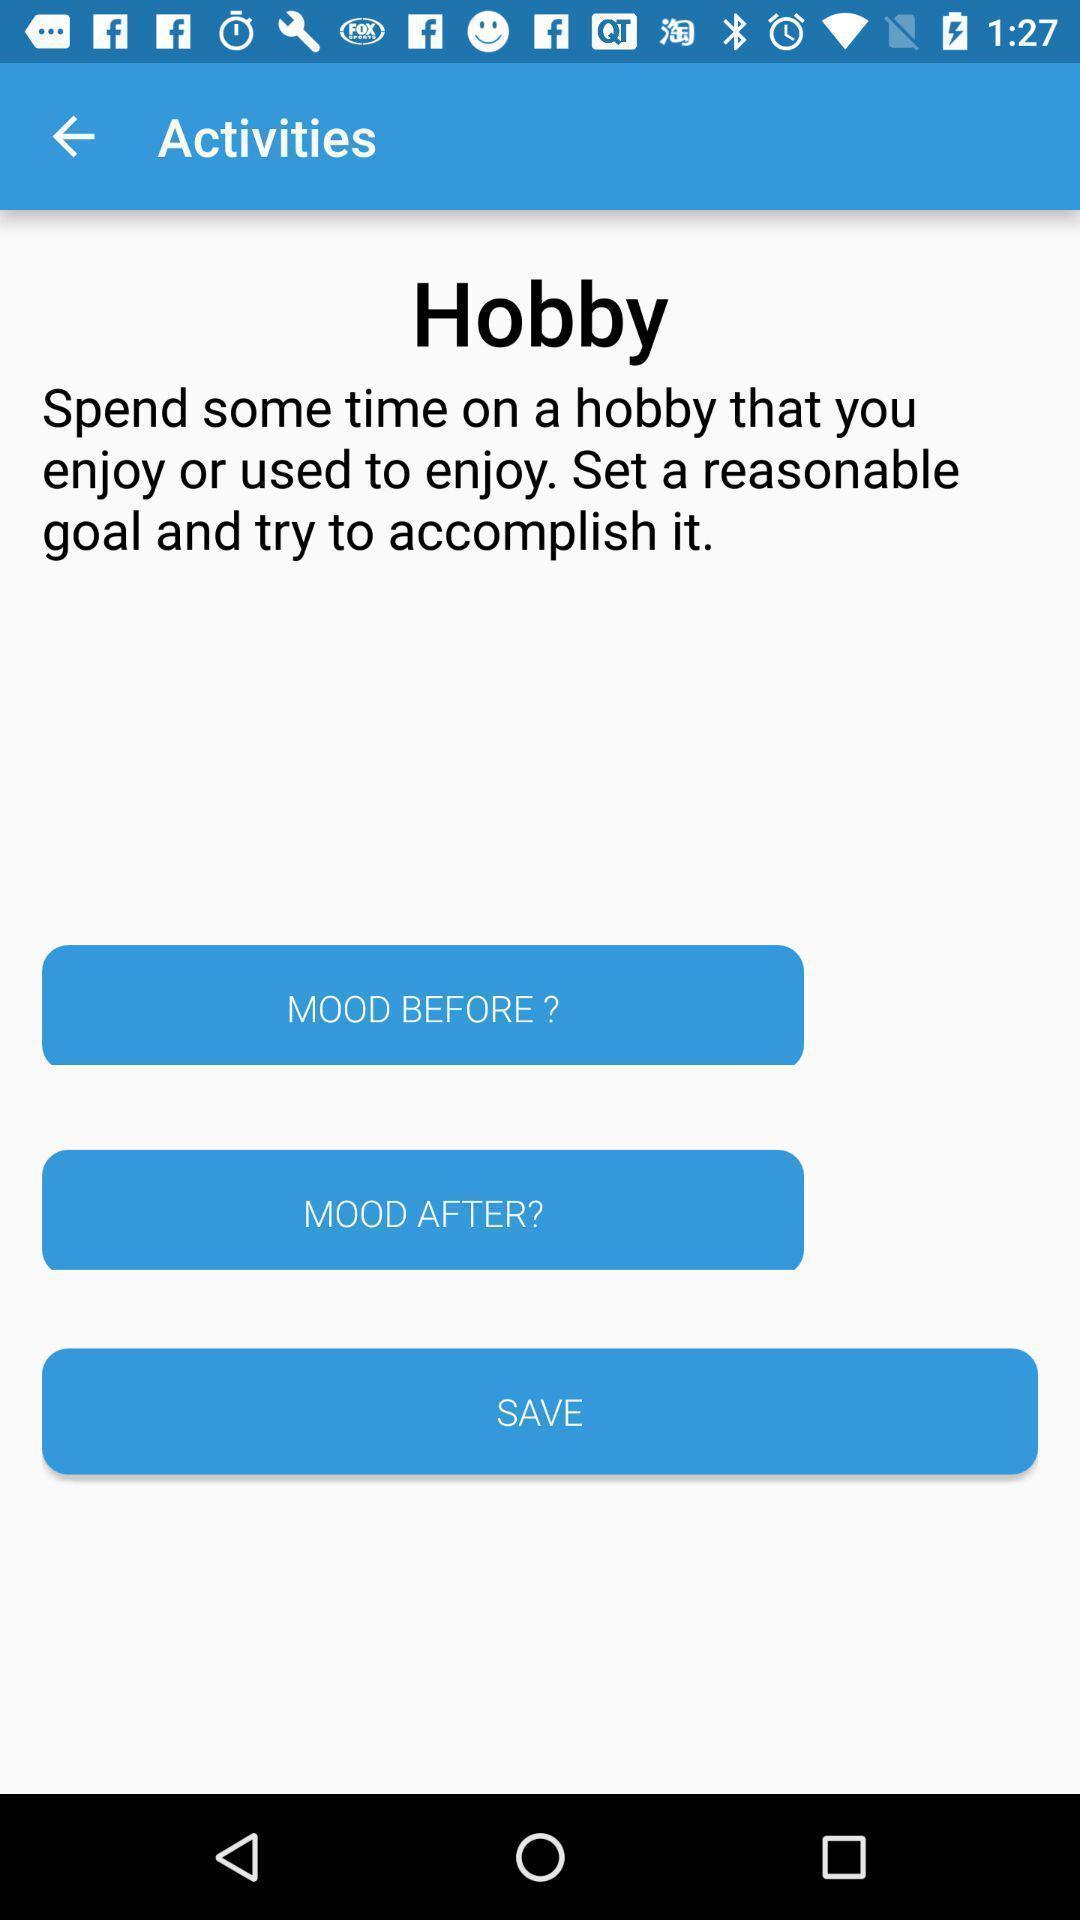Tell me about the visual elements in this screen capture. Screen shows few activities in a page. 